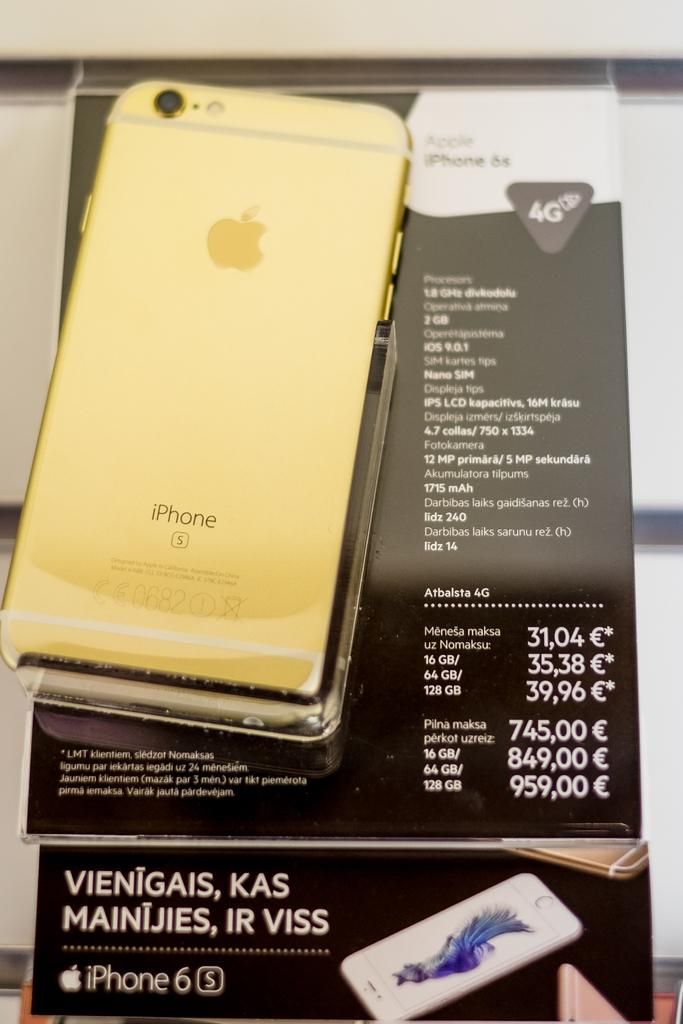Provide a one-sentence caption for the provided image. A gold colored iPhone6s is for sale in a European country. 